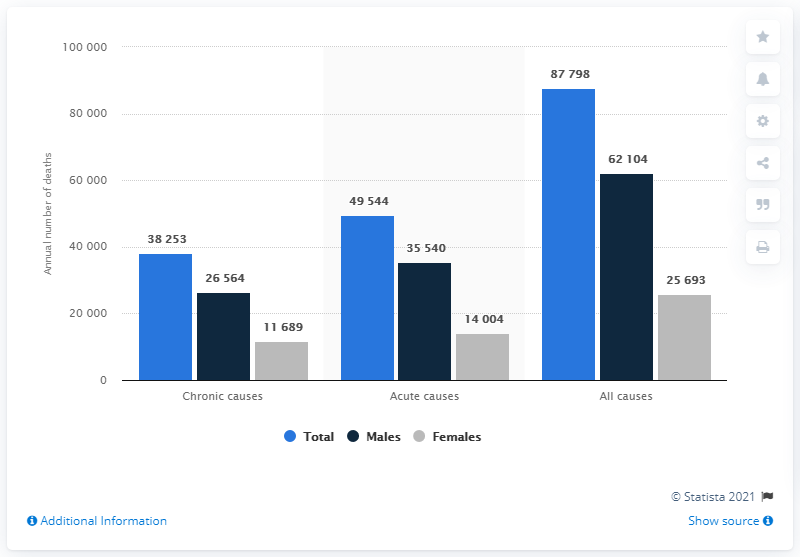Outline some significant characteristics in this image. During the years 2006 to 2010, a total of 87,798 deaths were attributed to excessive alcohol consumption. Out of the total number of deaths recorded, males made up 62,104 of them. 